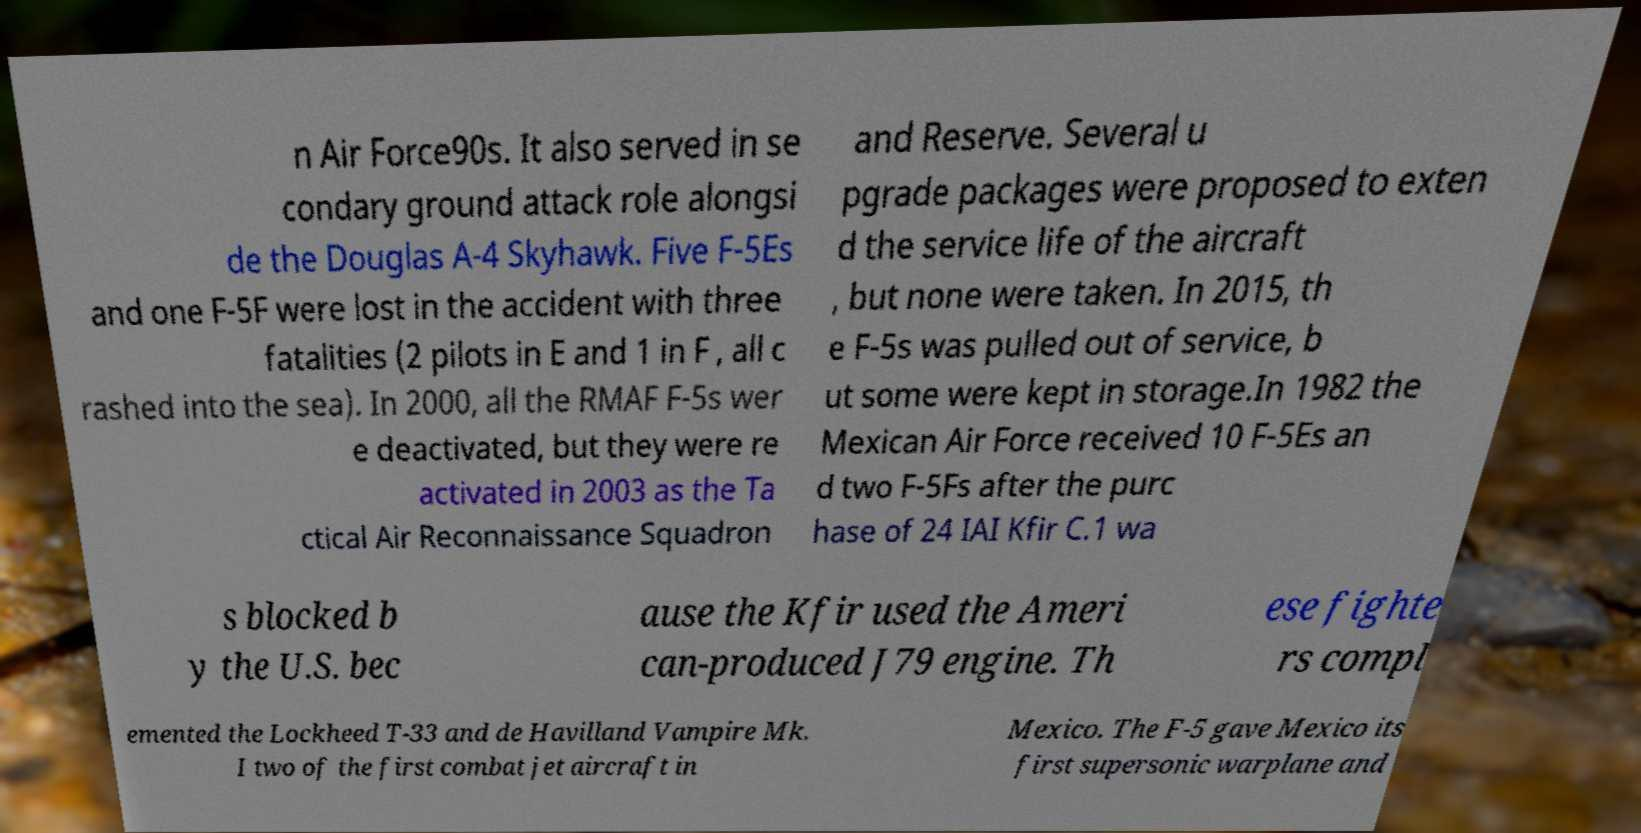Please read and relay the text visible in this image. What does it say? n Air Force90s. It also served in se condary ground attack role alongsi de the Douglas A-4 Skyhawk. Five F-5Es and one F-5F were lost in the accident with three fatalities (2 pilots in E and 1 in F , all c rashed into the sea). In 2000, all the RMAF F-5s wer e deactivated, but they were re activated in 2003 as the Ta ctical Air Reconnaissance Squadron and Reserve. Several u pgrade packages were proposed to exten d the service life of the aircraft , but none were taken. In 2015, th e F-5s was pulled out of service, b ut some were kept in storage.In 1982 the Mexican Air Force received 10 F-5Es an d two F-5Fs after the purc hase of 24 IAI Kfir C.1 wa s blocked b y the U.S. bec ause the Kfir used the Ameri can-produced J79 engine. Th ese fighte rs compl emented the Lockheed T-33 and de Havilland Vampire Mk. I two of the first combat jet aircraft in Mexico. The F-5 gave Mexico its first supersonic warplane and 